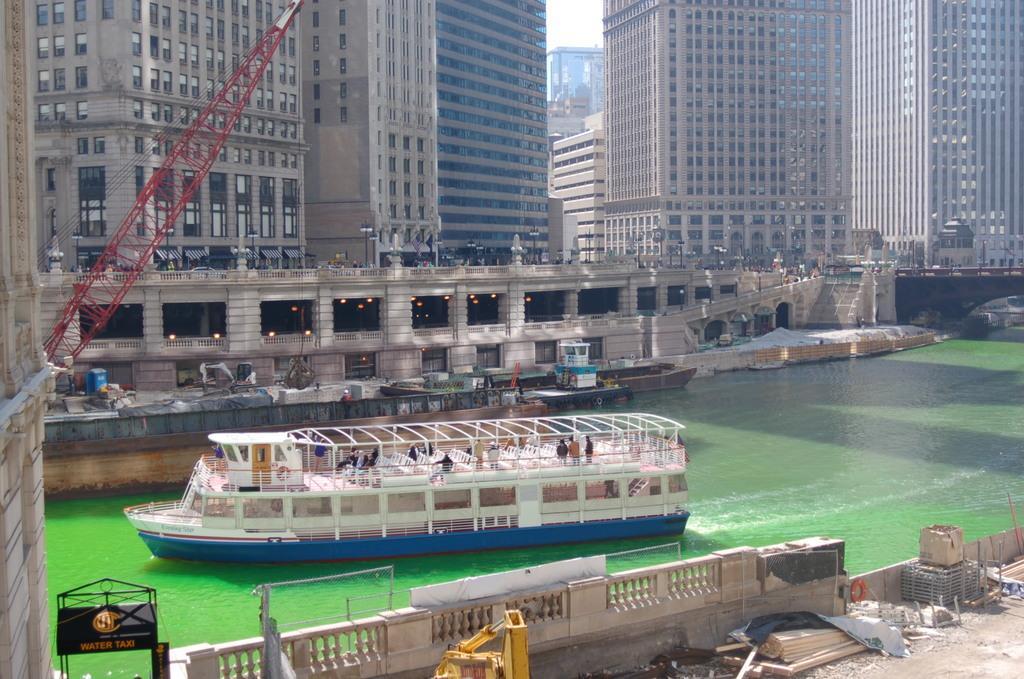Please provide a concise description of this image. In this image in the center there is a ship sailing on the water. In the front there is a railing. In the background there are buildings and there are lights. 